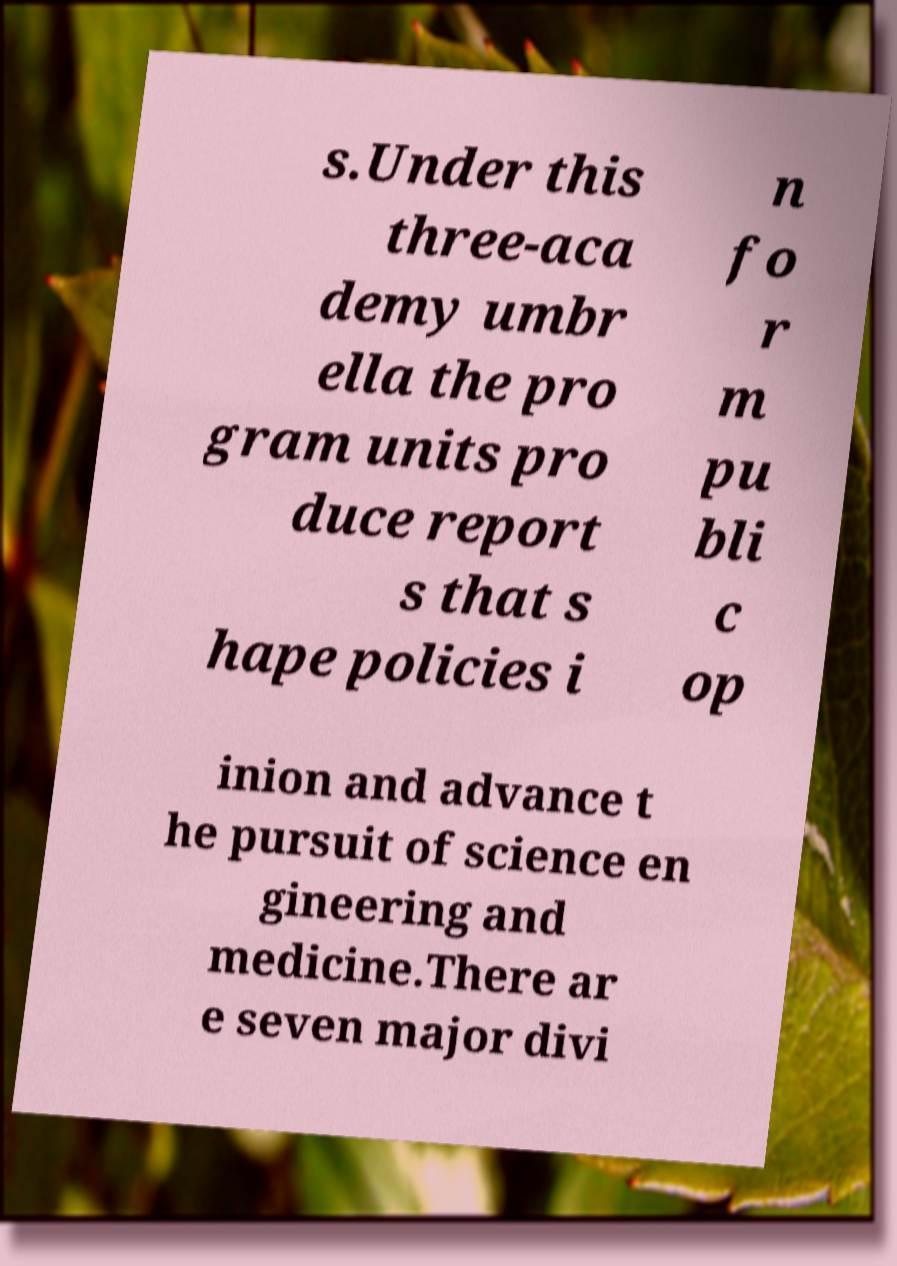For documentation purposes, I need the text within this image transcribed. Could you provide that? s.Under this three-aca demy umbr ella the pro gram units pro duce report s that s hape policies i n fo r m pu bli c op inion and advance t he pursuit of science en gineering and medicine.There ar e seven major divi 